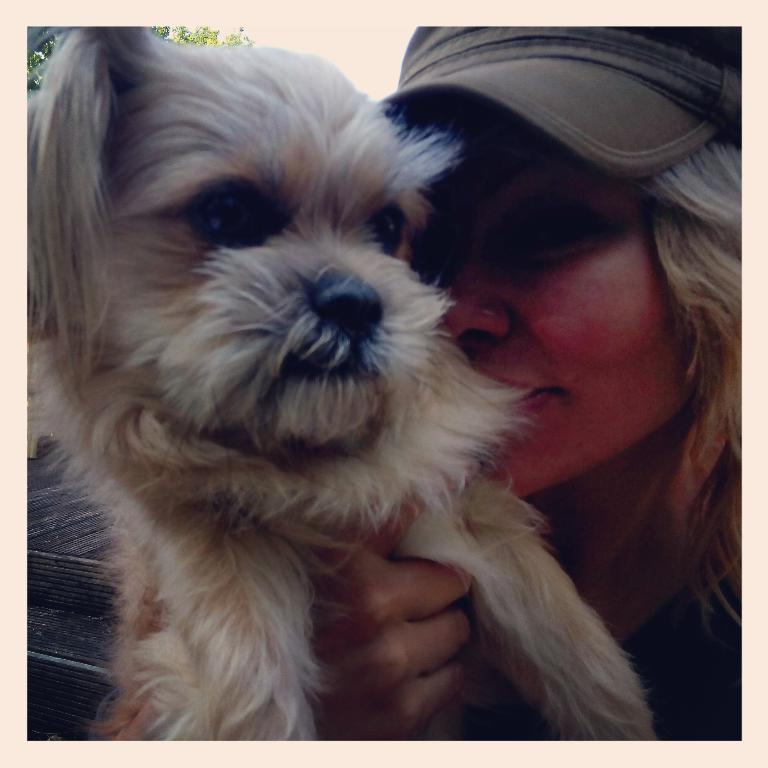Who is present in the image? There is a woman in the image. What is the woman holding? The woman is holding a dog. What is the woman wearing on her head? The woman is wearing a cap. What can be seen in the background of the image? There is a tree in the background of the image. What type of cracker is the woman feeding to the dog in the image? There is no cracker present in the image; the woman is holding a dog, but there is no indication of feeding it anything. 